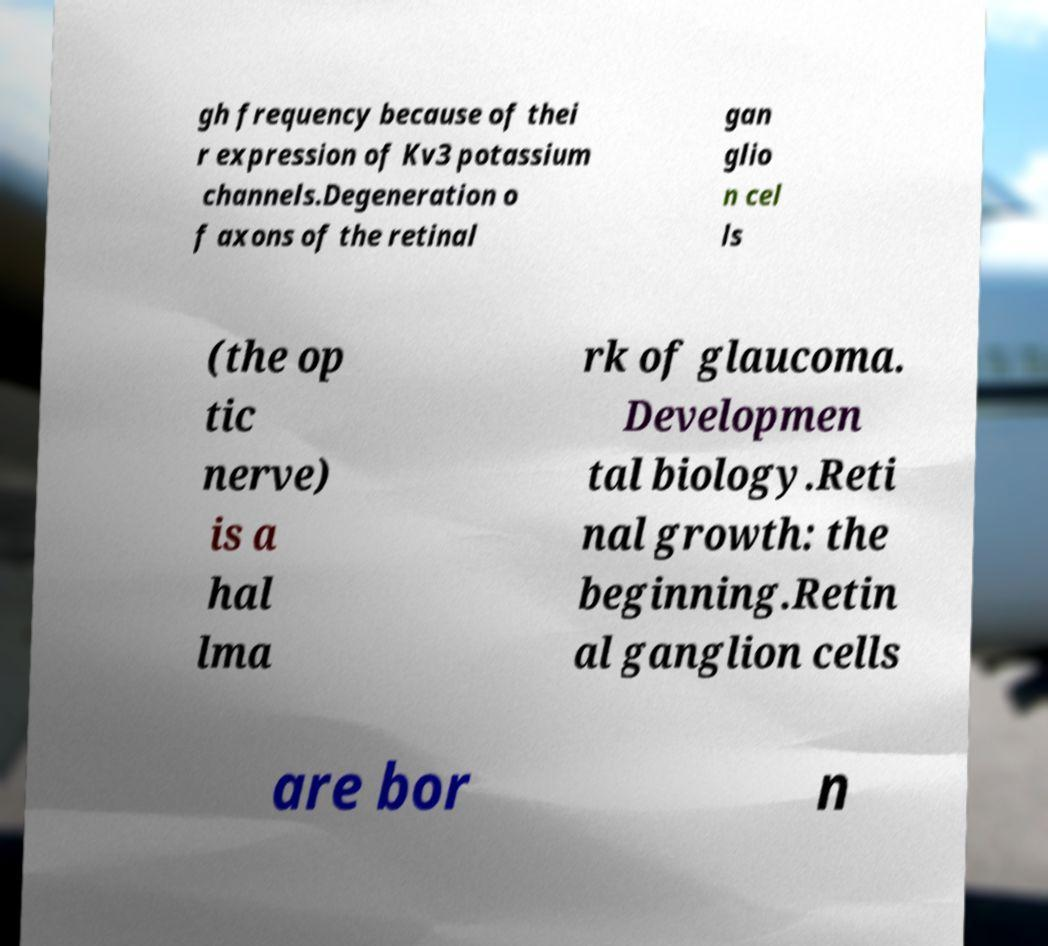Can you accurately transcribe the text from the provided image for me? gh frequency because of thei r expression of Kv3 potassium channels.Degeneration o f axons of the retinal gan glio n cel ls (the op tic nerve) is a hal lma rk of glaucoma. Developmen tal biology.Reti nal growth: the beginning.Retin al ganglion cells are bor n 